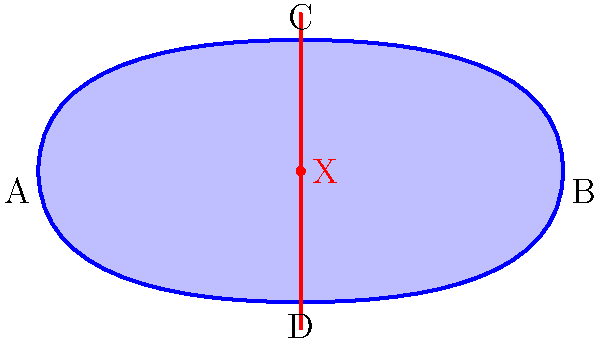In the context of avant-garde hairstyling, a Möbius strip-inspired design is created. If a stylist starts cutting along the red line from point X, how many full revolutions around the strip will they complete before returning to point X, and what will be the total length of the cut compared to the strip's original circumference? To answer this question, we need to understand the properties of a Möbius strip:

1. A Möbius strip has only one side and one edge.
2. If you trace a line along the center of the strip, you'll return to the starting point after traveling twice the strip's apparent length.

Now, let's analyze the cutting process:

1. The stylist starts cutting at point X along the red line.
2. As they cut, they'll travel along the surface of the strip.
3. Due to the Möbius strip's unique topology, the cut will continue on what seems to be the "other side" of the strip.
4. The stylist will complete two full revolutions around the strip before returning to point X.
5. During this process, they will have cut along the entire length of the strip.

Regarding the length of the cut:
- The cut follows the center line of the Möbius strip.
- This center line covers the entire length of the strip twice.
- Therefore, the total length of the cut will be equal to twice the strip's original circumference.

In terms of hairstyling, this property could inspire a design where a continuous cut or color application creates an illusion of depth and interconnectedness, challenging traditional notions of layering and sectioning in haircuts.
Answer: 2 revolutions; twice the original circumference 